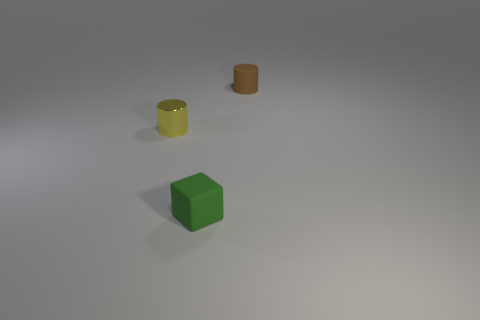What number of green blocks have the same material as the brown object?
Offer a terse response. 1. How many shiny cylinders are on the right side of the tiny rubber thing in front of the tiny brown cylinder?
Make the answer very short. 0. What shape is the small thing that is both on the left side of the small brown thing and to the right of the yellow object?
Make the answer very short. Cube. Are there any other objects that have the same shape as the brown object?
Give a very brief answer. Yes. What is the shape of the green object that is the same size as the metallic cylinder?
Your response must be concise. Cube. What material is the brown object?
Provide a succinct answer. Rubber. What number of metallic objects are small cylinders or small gray cubes?
Offer a very short reply. 1. How many objects are either gray rubber blocks or tiny objects that are right of the green thing?
Give a very brief answer. 1. How many other things are the same color as the matte cylinder?
Keep it short and to the point. 0. Is the size of the yellow metal cylinder the same as the thing that is behind the small yellow thing?
Keep it short and to the point. Yes. 